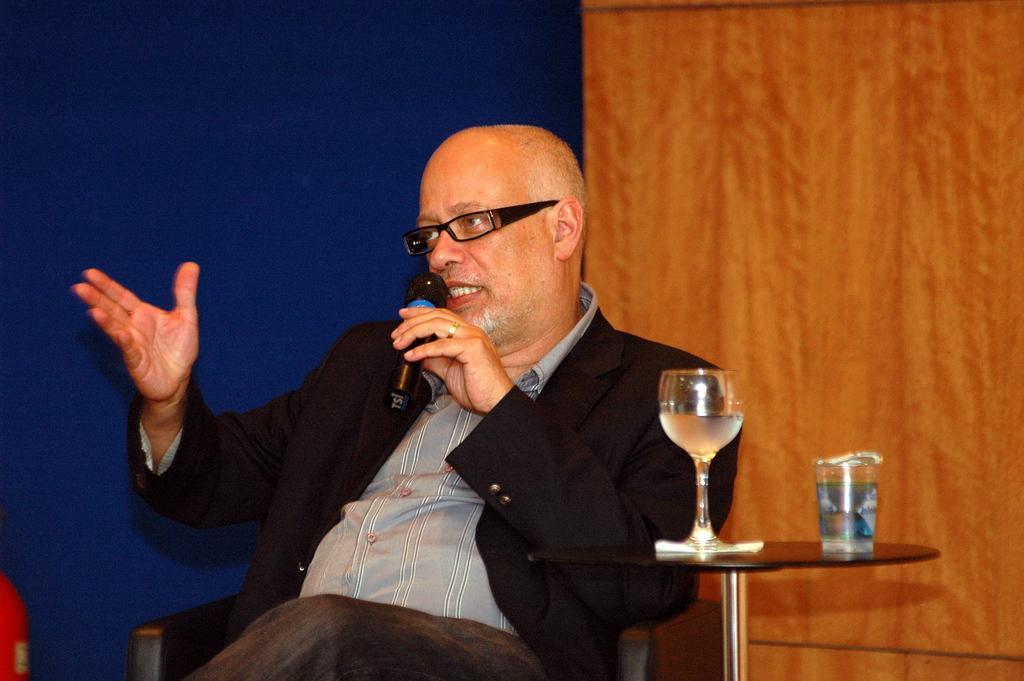In one or two sentences, can you explain what this image depicts? In this image there is a man sitting on a chair. He is holding a microphone in his hand. Beside him there is a table. There are glasses on the table. Behind him there is a wall. 